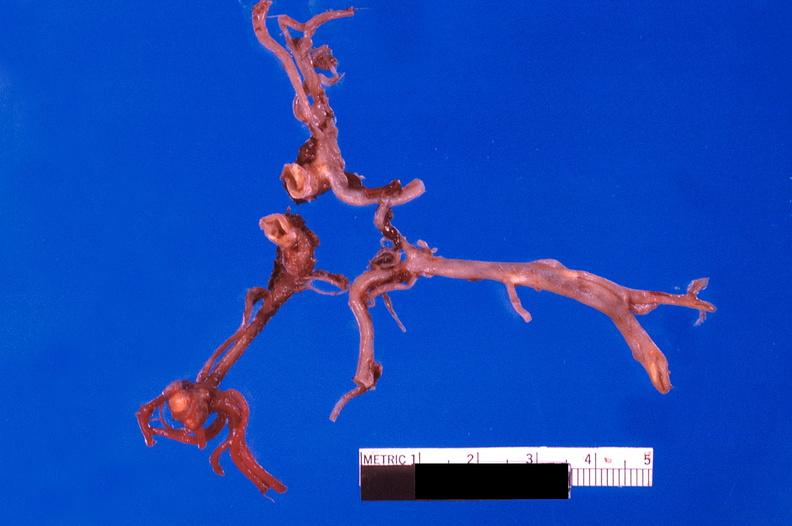where is this?
Answer the question using a single word or phrase. Vasculature 